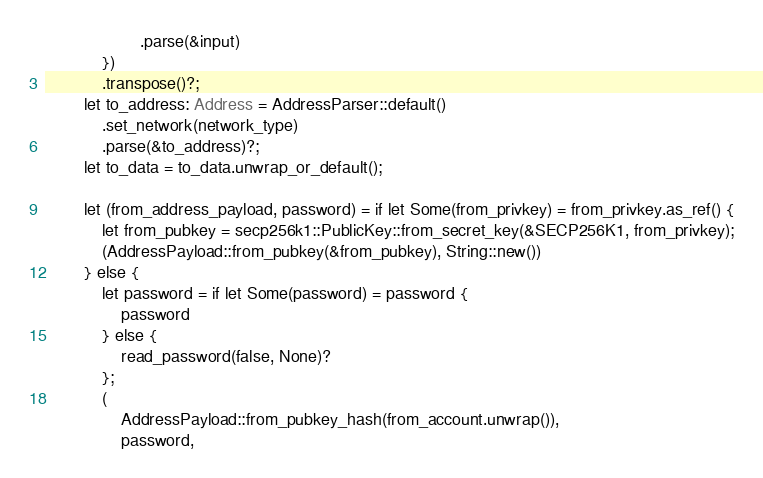Convert code to text. <code><loc_0><loc_0><loc_500><loc_500><_Rust_>                    .parse(&input)
            })
            .transpose()?;
        let to_address: Address = AddressParser::default()
            .set_network(network_type)
            .parse(&to_address)?;
        let to_data = to_data.unwrap_or_default();

        let (from_address_payload, password) = if let Some(from_privkey) = from_privkey.as_ref() {
            let from_pubkey = secp256k1::PublicKey::from_secret_key(&SECP256K1, from_privkey);
            (AddressPayload::from_pubkey(&from_pubkey), String::new())
        } else {
            let password = if let Some(password) = password {
                password
            } else {
                read_password(false, None)?
            };
            (
                AddressPayload::from_pubkey_hash(from_account.unwrap()),
                password,</code> 